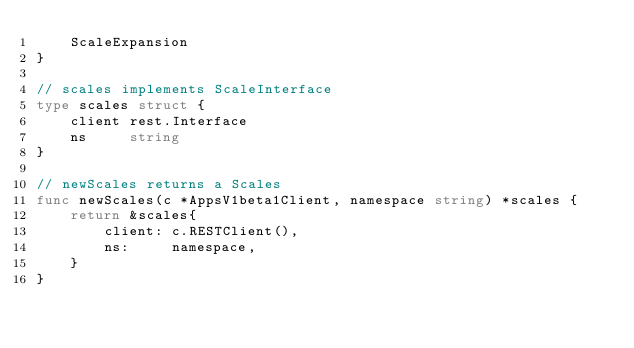Convert code to text. <code><loc_0><loc_0><loc_500><loc_500><_Go_>	ScaleExpansion
}

// scales implements ScaleInterface
type scales struct {
	client rest.Interface
	ns     string
}

// newScales returns a Scales
func newScales(c *AppsV1beta1Client, namespace string) *scales {
	return &scales{
		client: c.RESTClient(),
		ns:     namespace,
	}
}
</code> 